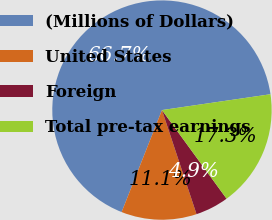Convert chart. <chart><loc_0><loc_0><loc_500><loc_500><pie_chart><fcel>(Millions of Dollars)<fcel>United States<fcel>Foreign<fcel>Total pre-tax earnings<nl><fcel>66.7%<fcel>11.1%<fcel>4.92%<fcel>17.28%<nl></chart> 